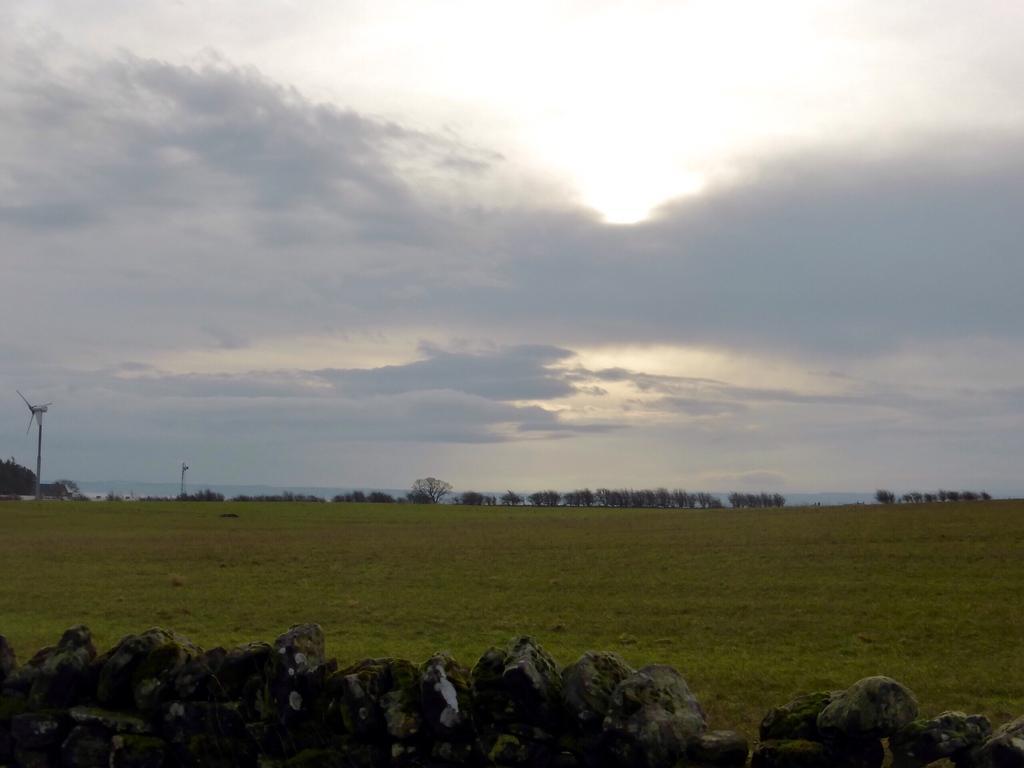Could you give a brief overview of what you see in this image? In this image we can see the grass, rocks and also trees. There is a cloudy sky. 